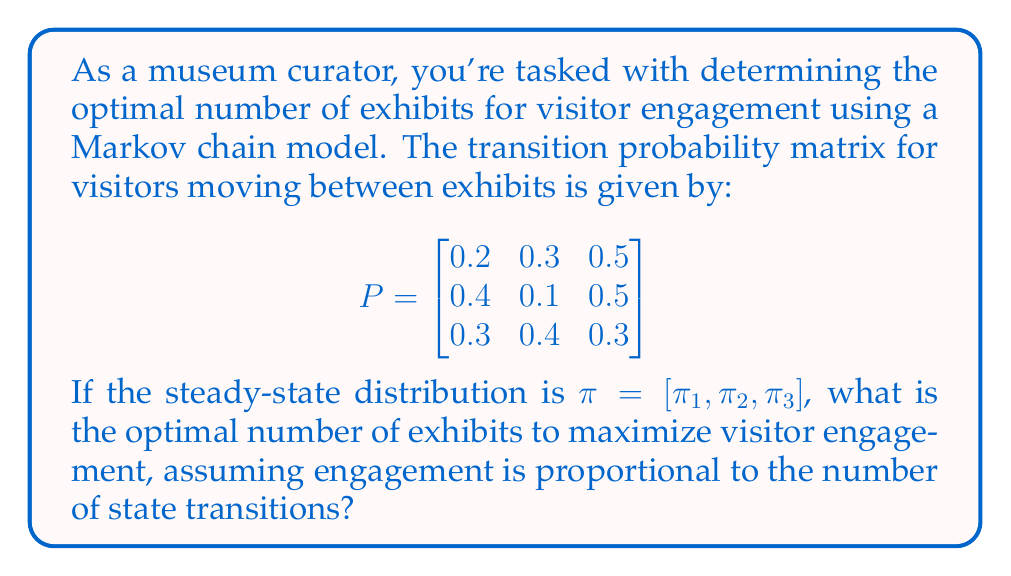Solve this math problem. To solve this problem, we'll follow these steps:

1) First, we need to find the steady-state distribution $\pi$ by solving the equation:

   $$\pi P = \pi$$

   This gives us the system of equations:
   $$\begin{cases}
   0.2\pi_1 + 0.4\pi_2 + 0.3\pi_3 = \pi_1 \\
   0.3\pi_1 + 0.1\pi_2 + 0.4\pi_3 = \pi_2 \\
   0.5\pi_1 + 0.5\pi_2 + 0.3\pi_3 = \pi_3
   \end{cases}$$

2) Along with the condition that probabilities sum to 1:

   $$\pi_1 + \pi_2 + \pi_3 = 1$$

3) Solving this system (you can use a computer algebra system), we get:

   $$\pi = [0.3448, 0.2759, 0.3793]$$

4) The probability of transitioning between states (not staying in the same state) for each state is:

   State 1: $1 - 0.2 = 0.8$
   State 2: $1 - 0.1 = 0.9$
   State 3: $1 - 0.3 = 0.7$

5) The expected number of transitions per step is:

   $$0.3448 * 0.8 + 0.2759 * 0.9 + 0.3793 * 0.7 = 0.7931$$

6) The expected number of steps before returning to the same state (mean recurrence time) for each state is:

   State 1: $1/0.3448 = 2.9$
   State 2: $1/0.2759 = 3.6$
   State 3: $1/0.3793 = 2.6$

7) The state with the highest mean recurrence time corresponds to the optimal number of exhibits, as it maximizes the expected number of transitions before returning to the same exhibit.

Therefore, the optimal number of exhibits is 2, corresponding to State 2 with the highest mean recurrence time of 3.6.
Answer: 2 exhibits 